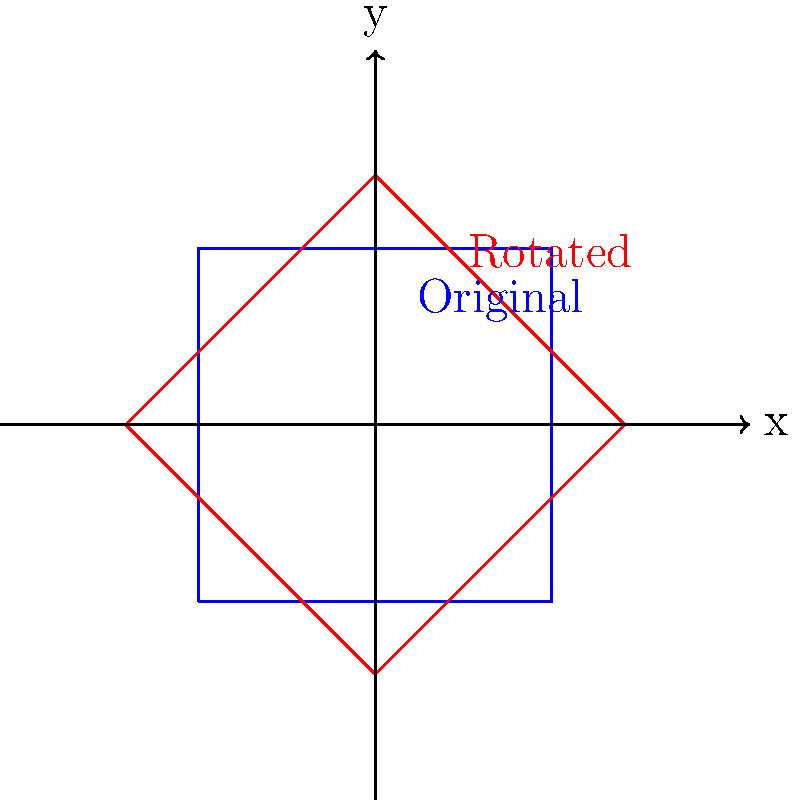As part of a community development initiative, you're reviewing a blueprint for a new community center. The current design is represented by a square with sides parallel to the x and y axes. To optimize space usage, it's proposed to rotate the building by 45°. If the original square had a side length of 100 feet, what is the new width of the rotated building along the x-axis? To solve this problem, we'll follow these steps:

1) The original square has sides parallel to the x and y axes, with a side length of 100 feet.

2) After rotation by 45°, the square becomes a diamond shape when viewed in relation to the original axes.

3) To find the new width along the x-axis, we need to calculate the diagonal of the original square, as this will become the new width.

4) The diagonal of a square can be calculated using the Pythagorean theorem:
   $$d^2 = s^2 + s^2 = 2s^2$$
   where $d$ is the diagonal and $s$ is the side length.

5) Substituting our side length of 100 feet:
   $$d^2 = 2(100^2) = 20,000$$

6) Taking the square root of both sides:
   $$d = \sqrt{20,000} = 100\sqrt{2}$$

7) Therefore, the new width along the x-axis is $100\sqrt{2}$ feet.

8) If we need a decimal approximation: $100\sqrt{2} \approx 141.4$ feet
Answer: $100\sqrt{2}$ feet 